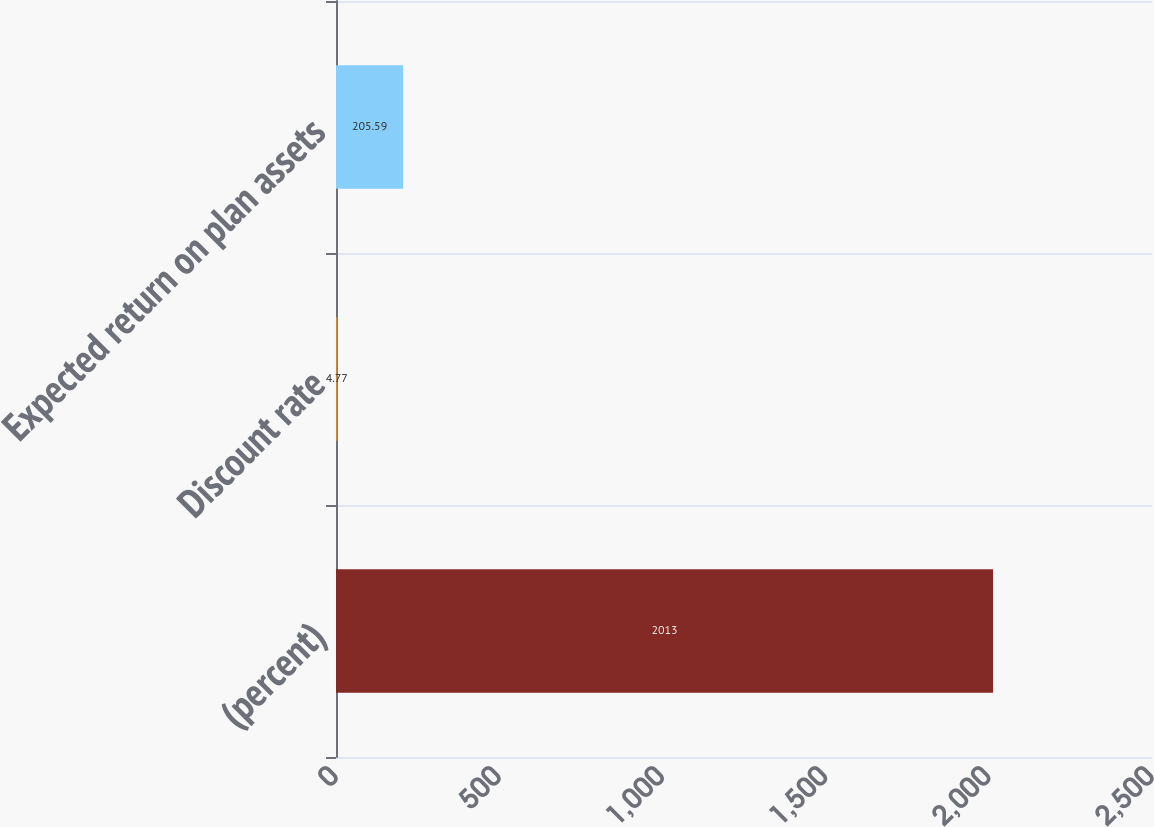<chart> <loc_0><loc_0><loc_500><loc_500><bar_chart><fcel>(percent)<fcel>Discount rate<fcel>Expected return on plan assets<nl><fcel>2013<fcel>4.77<fcel>205.59<nl></chart> 